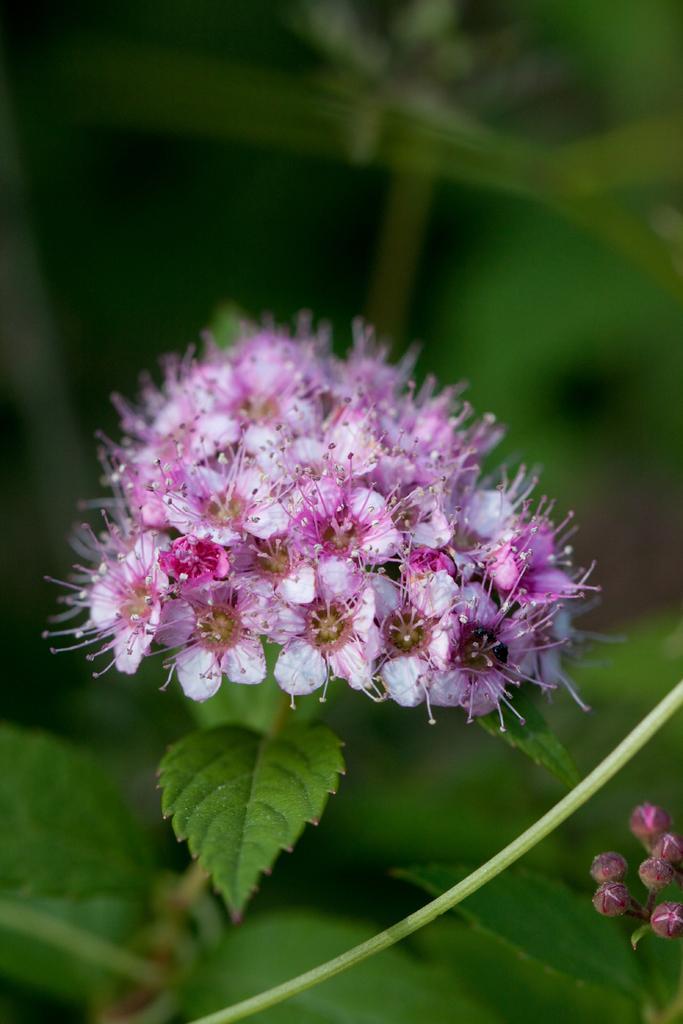Can you describe this image briefly? In this image I can see pink and white colour flowers in the front. I can also see green leaves and on the bottom right side of the image I can see few buds. I can also see this image is little bit blurry in the background. 